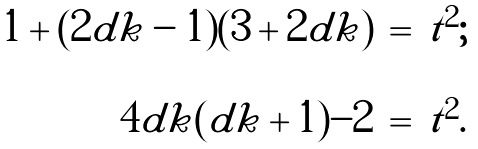Convert formula to latex. <formula><loc_0><loc_0><loc_500><loc_500>\begin{array} { r c l } 1 + ( 2 d k - 1 ) ( 3 + 2 d k ) & = & t ^ { 2 } ; \\ \\ 4 d k ( d k + 1 ) - 2 & = & t ^ { 2 } . \end{array}</formula> 